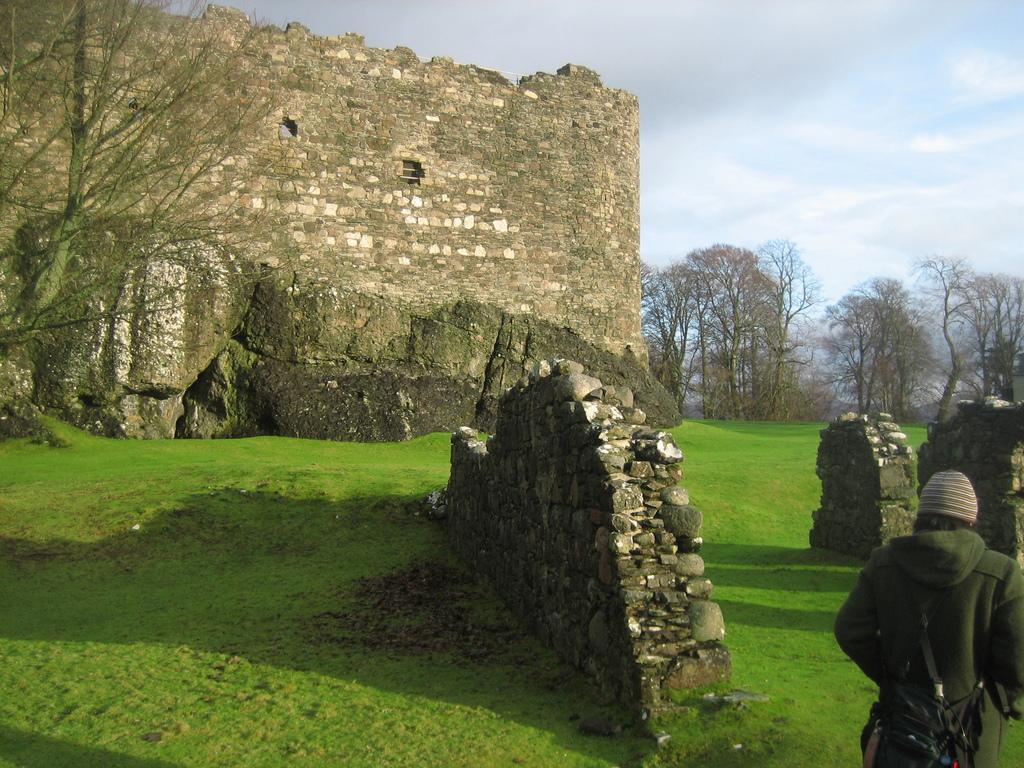Could you give a brief overview of what you see in this image? In this image we can see a monument, person walking on the ground, trees and sky with clouds. 